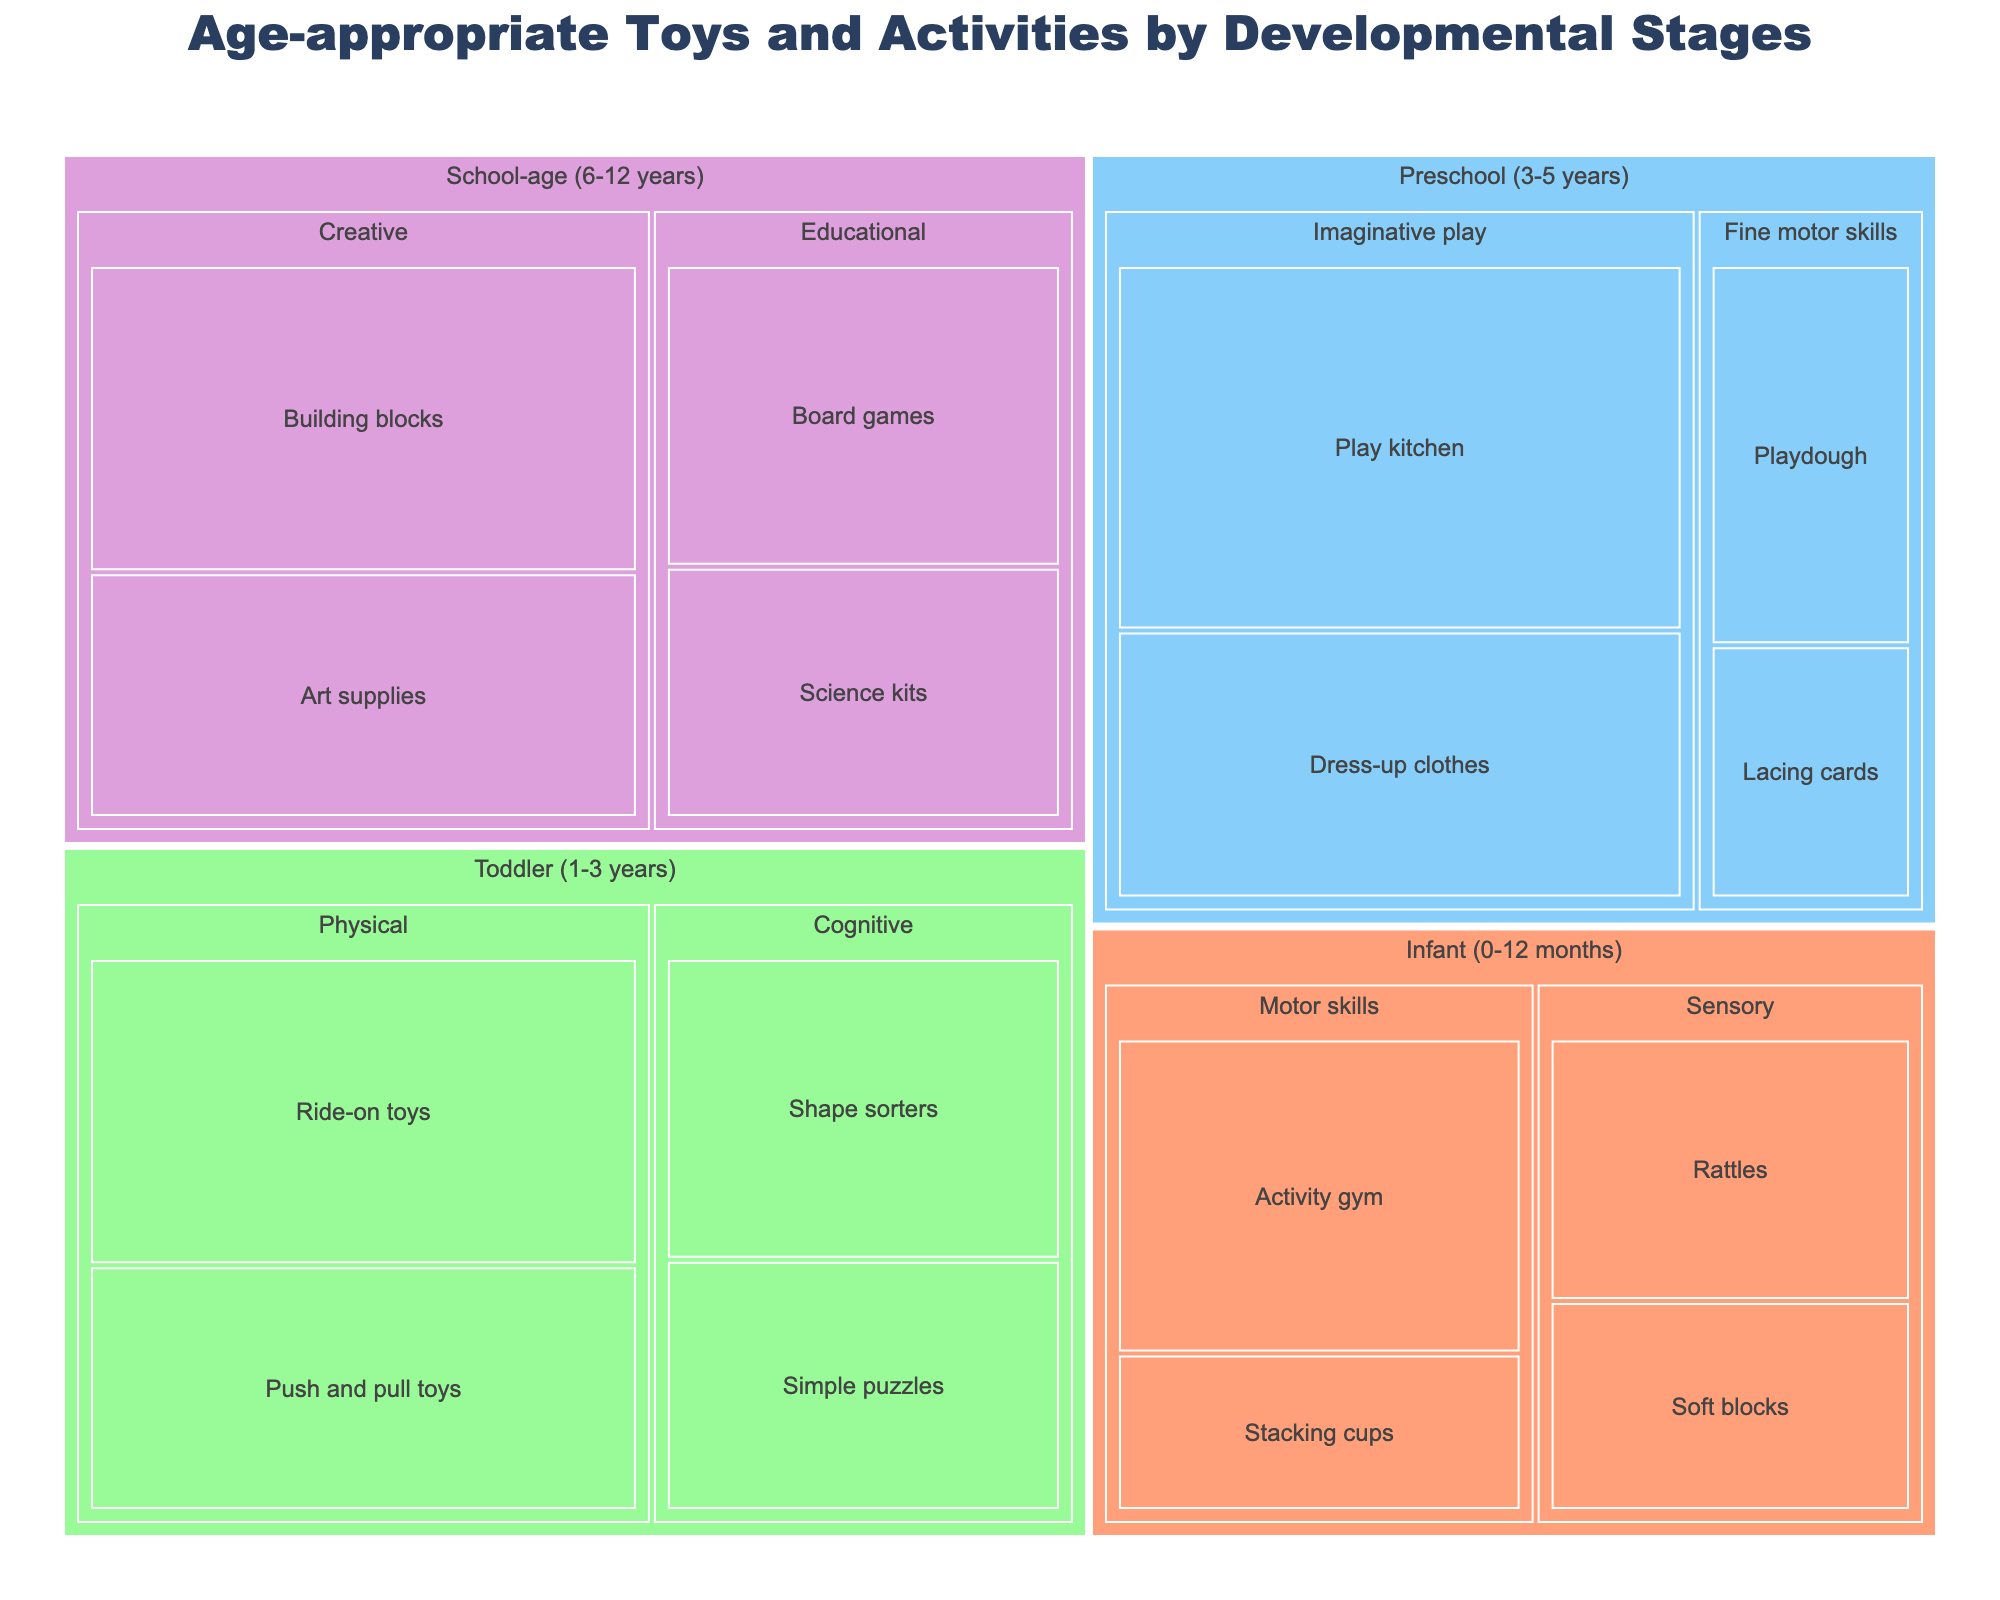What is the title of the Treemap? The title is usually found at the top of the figure and often summarizes the content of the chart. In this case, the title provides an overview of the chart's main purpose and categorization.
Answer: Age-appropriate Toys and Activities by Developmental Stages How many developmental stages are shown in the Treemap? The chart is divided into distinct categories by colors, each representing a developmental stage. You can count the number of unique colors or stages listed.
Answer: Four Which item has the highest value in the Toddler (1-3 years) category? Locate the Toddler (1-3 years) section and look for the item with the largest area, which indicates the highest value within that category.
Answer: Ride-on toys What are the values of Science kits and Board games in the School-age (6-12 years) category? Identify the School-age (6-12 years) category and read the values associated with Science kits and Board games. This requires locating the appropriate subcategories and their items.
Answer: 15 and 18 Which developmental stage has the largest total value? Sum the values of items within each category and compare. For example, add the values within the Infant, Toddler, Preschool, and School-age categories, and determine the highest total.
Answer: Toddler (1-3 years) What is the difference in value between the Play kitchen and Ride-on toys? Locate the values for Play kitchen in the Preschool category and Ride-on toys in the Toddler category, then subtract the smaller value from the larger value to find the difference.
Answer: 5 Which category contains the most distinct subcategories? Check each developmental stage and count the number of different subcategories present. Compare these counts to find the category with the highest number.
Answer: Preschool (3-5 years) What is the average value of items in the Sensory subcategory within the Infant (0-12 months) category? Sum the values of Rattles and Soft blocks, then divide by the number of items (2) to calculate the average value.
Answer: 13.5 Are there more items in the Fine motor skills subcategory or the Educational subcategory? Count the number of items listed under Fine motor skills in Preschool and Educational in School-age and compare the counts.
Answer: Fine motor skills Which has a higher total value: items in the Physical subcategory in Toddler (1-3 years) or the Creative subcategory in School-age (6-12 years)? Sum the values for items in the Physical subcategory (Push and pull toys and Ride-on toys) and the Creative subcategory (Art supplies and Building blocks), then compare the two totals.
Answer: Creative subcategory (45) 